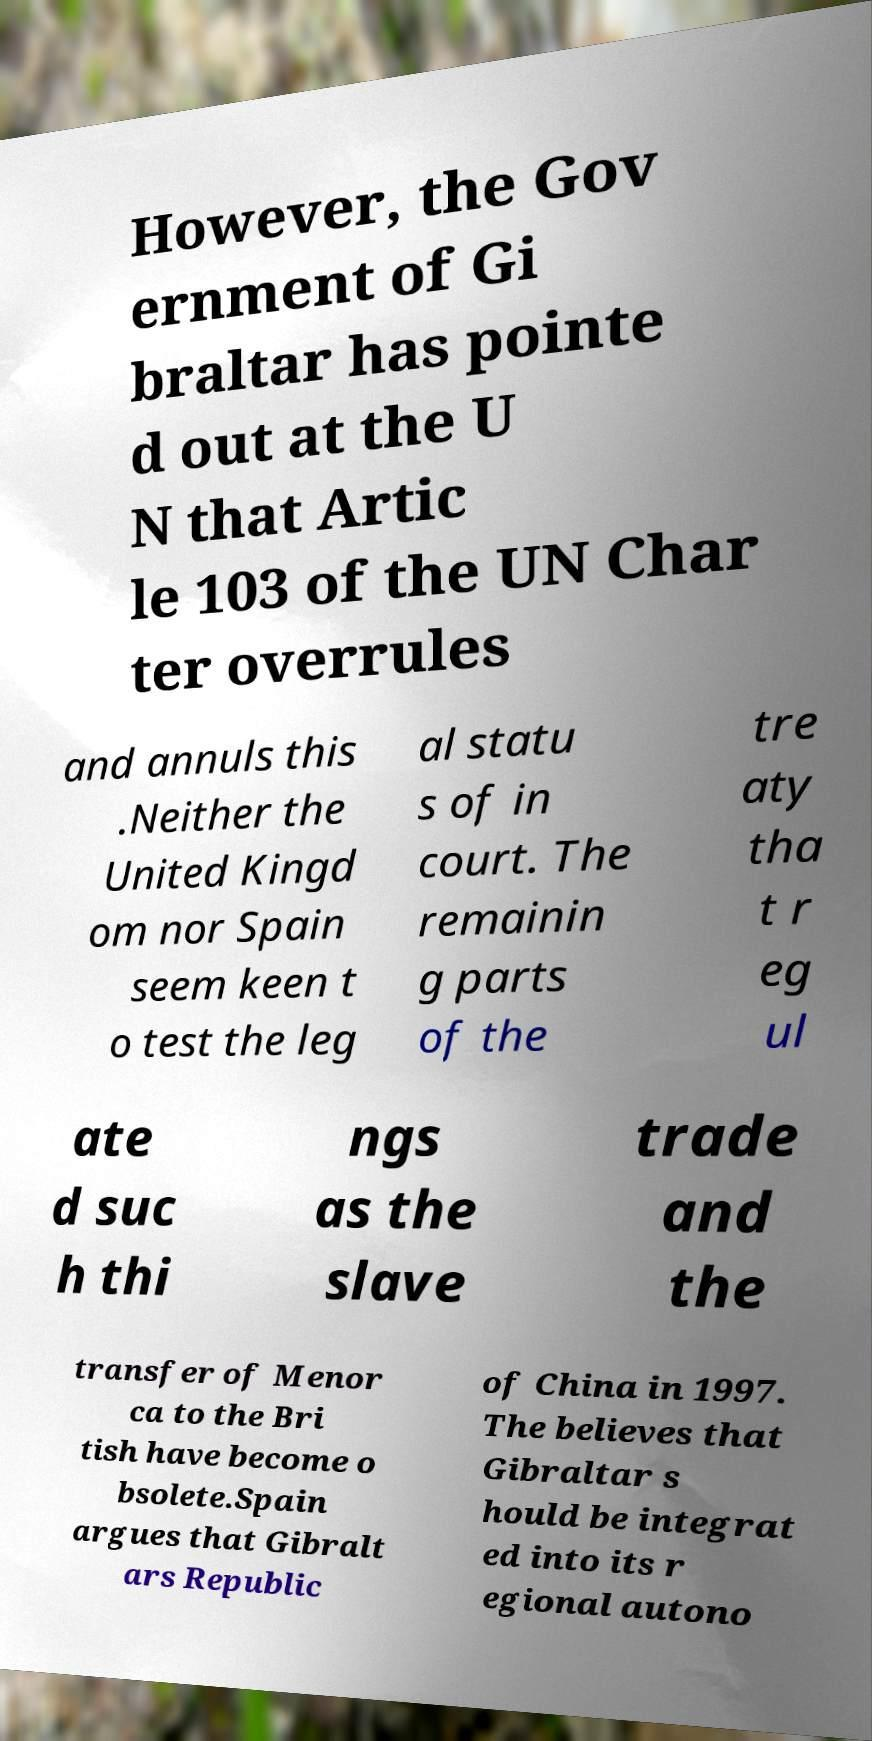Could you assist in decoding the text presented in this image and type it out clearly? However, the Gov ernment of Gi braltar has pointe d out at the U N that Artic le 103 of the UN Char ter overrules and annuls this .Neither the United Kingd om nor Spain seem keen t o test the leg al statu s of in court. The remainin g parts of the tre aty tha t r eg ul ate d suc h thi ngs as the slave trade and the transfer of Menor ca to the Bri tish have become o bsolete.Spain argues that Gibralt ars Republic of China in 1997. The believes that Gibraltar s hould be integrat ed into its r egional autono 